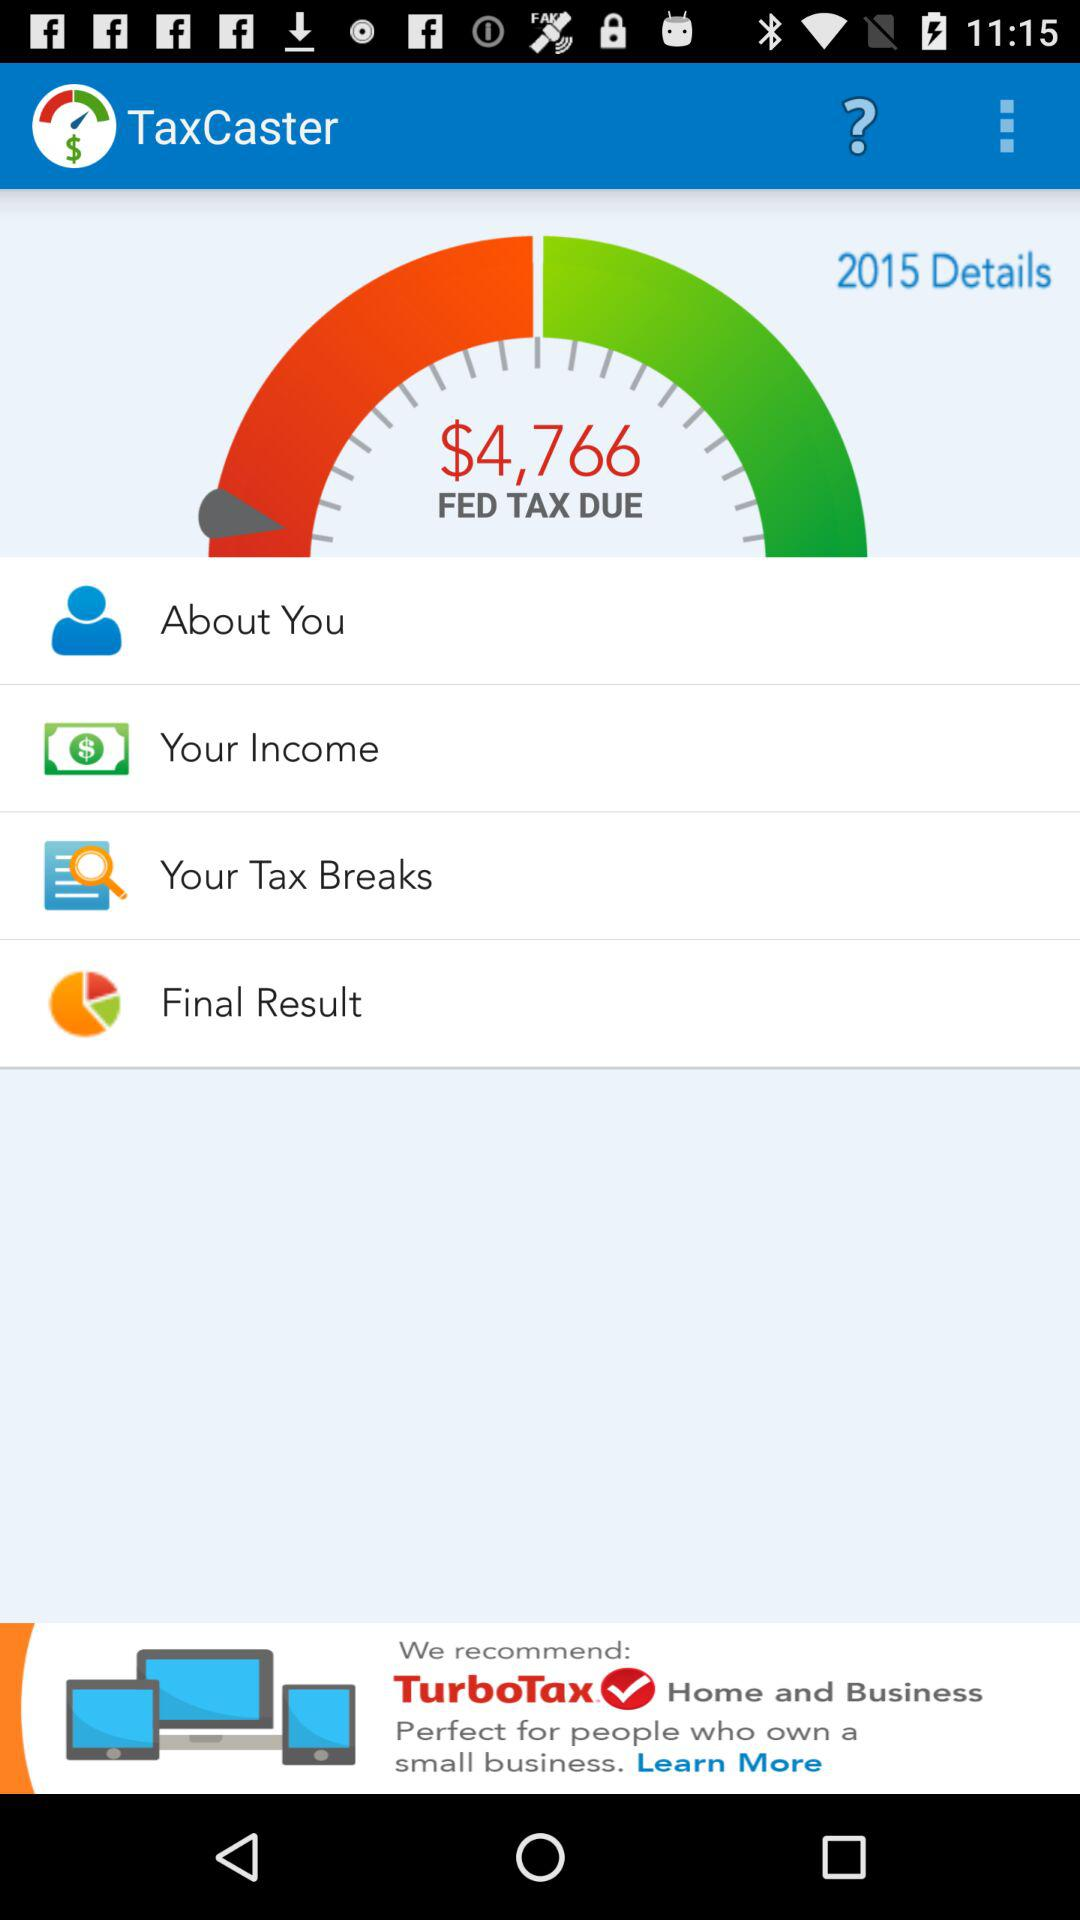How much tax is due in the "TaxCaster"? The amount of tax due in the "TaxCaster" is $4,766. 